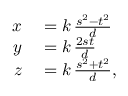<formula> <loc_0><loc_0><loc_500><loc_500>\begin{array} { r l } { x } & = k \, { \frac { s ^ { 2 } - t ^ { 2 } } { d } } } \\ { y } & = k \, { \frac { 2 s t } { d } } } \\ { z } & = k \, { \frac { s ^ { 2 } + t ^ { 2 } } { d } } , } \end{array}</formula> 